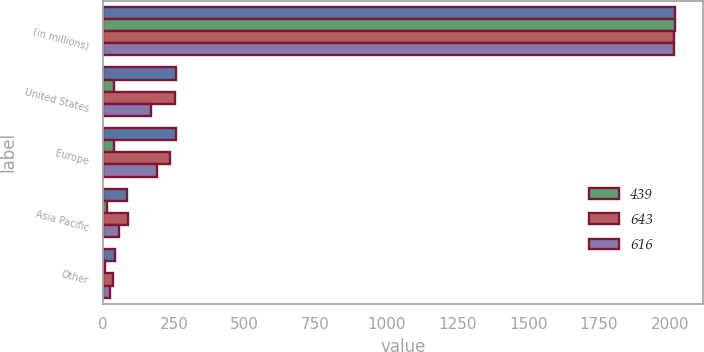<chart> <loc_0><loc_0><loc_500><loc_500><stacked_bar_chart><ecel><fcel>(in millions)<fcel>United States<fcel>Europe<fcel>Asia Pacific<fcel>Other<nl><fcel>nan<fcel>2017<fcel>258<fcel>259<fcel>85<fcel>41<nl><fcel>439<fcel>2017<fcel>40<fcel>40<fcel>13<fcel>7<nl><fcel>643<fcel>2016<fcel>255<fcel>237<fcel>87<fcel>37<nl><fcel>616<fcel>2015<fcel>168<fcel>189<fcel>56<fcel>26<nl></chart> 